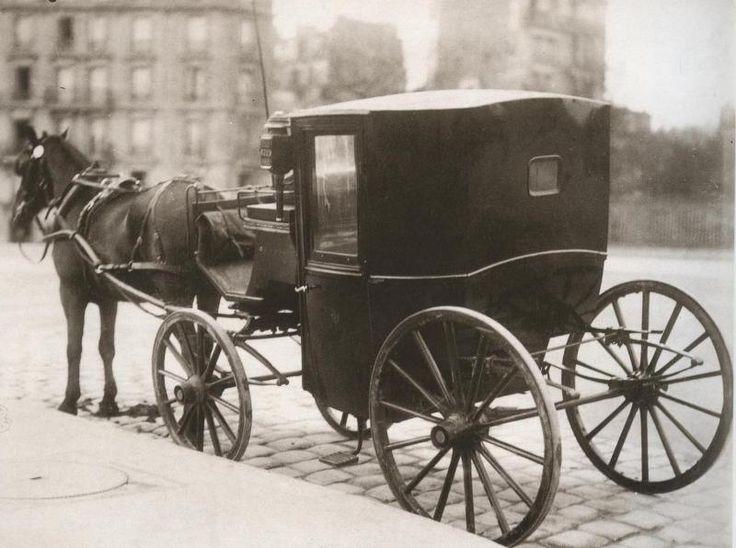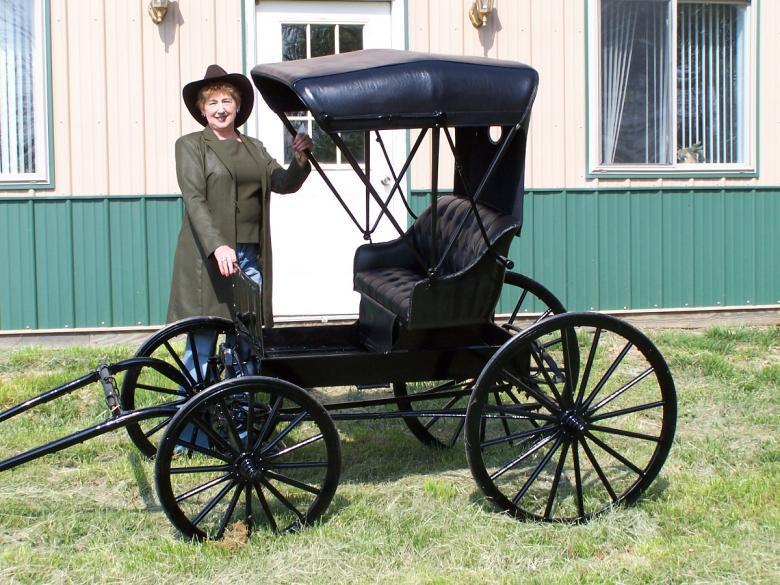The first image is the image on the left, the second image is the image on the right. Considering the images on both sides, is "The carriages in both photos are facing to the left." valid? Answer yes or no. Yes. The first image is the image on the left, the second image is the image on the right. Considering the images on both sides, is "At least one cart is facing toward the right." valid? Answer yes or no. No. 